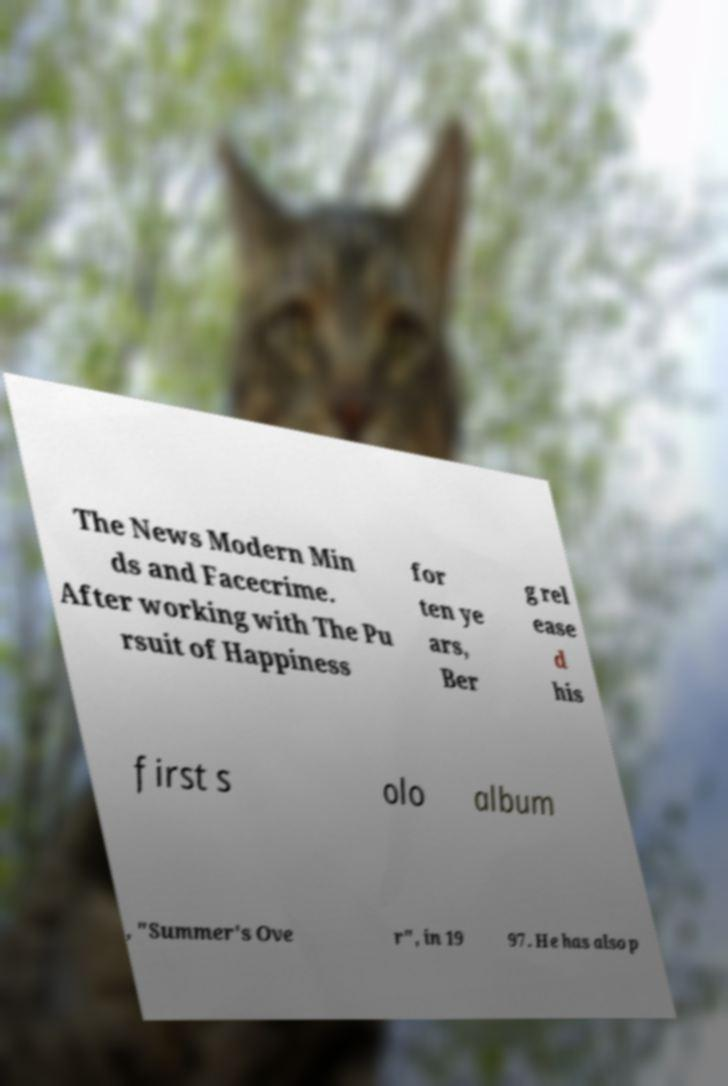There's text embedded in this image that I need extracted. Can you transcribe it verbatim? The News Modern Min ds and Facecrime. After working with The Pu rsuit of Happiness for ten ye ars, Ber g rel ease d his first s olo album , "Summer's Ove r", in 19 97. He has also p 